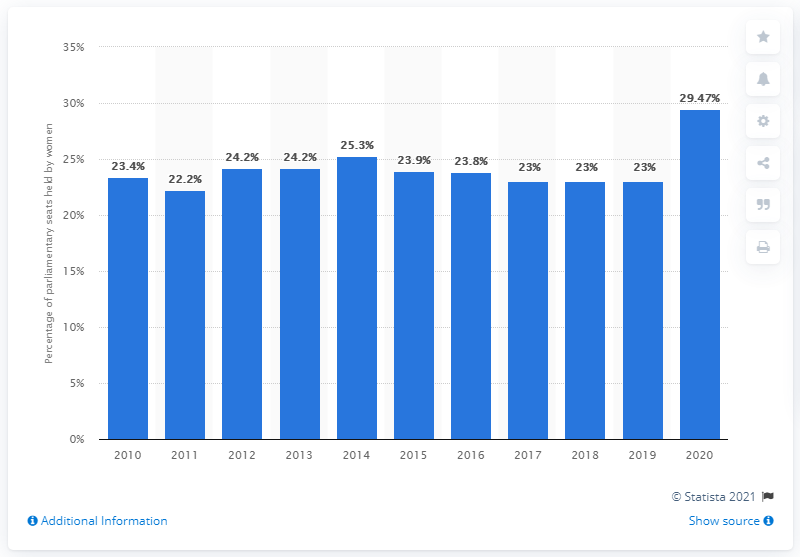Draw attention to some important aspects in this diagram. In 2019, women held 29.47% of the seats in Singapore's parliament. In 2019, the percentage of female parliamentarians in Singapore was 23%. In 2020, a record number of women entered parliament. 